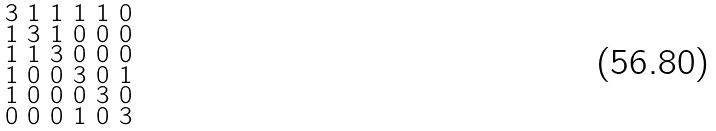<formula> <loc_0><loc_0><loc_500><loc_500>\begin{smallmatrix} 3 & 1 & 1 & 1 & 1 & 0 \\ 1 & 3 & 1 & 0 & 0 & 0 \\ 1 & 1 & 3 & 0 & 0 & 0 \\ 1 & 0 & 0 & 3 & 0 & 1 \\ 1 & 0 & 0 & 0 & 3 & 0 \\ 0 & 0 & 0 & 1 & 0 & 3 \end{smallmatrix}</formula> 